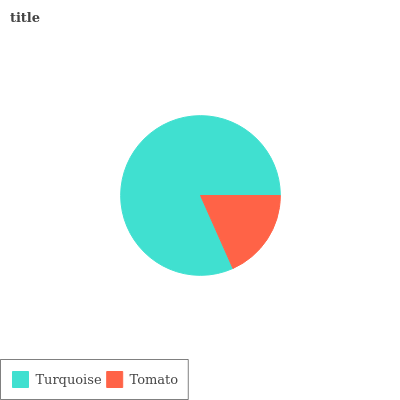Is Tomato the minimum?
Answer yes or no. Yes. Is Turquoise the maximum?
Answer yes or no. Yes. Is Tomato the maximum?
Answer yes or no. No. Is Turquoise greater than Tomato?
Answer yes or no. Yes. Is Tomato less than Turquoise?
Answer yes or no. Yes. Is Tomato greater than Turquoise?
Answer yes or no. No. Is Turquoise less than Tomato?
Answer yes or no. No. Is Turquoise the high median?
Answer yes or no. Yes. Is Tomato the low median?
Answer yes or no. Yes. Is Tomato the high median?
Answer yes or no. No. Is Turquoise the low median?
Answer yes or no. No. 